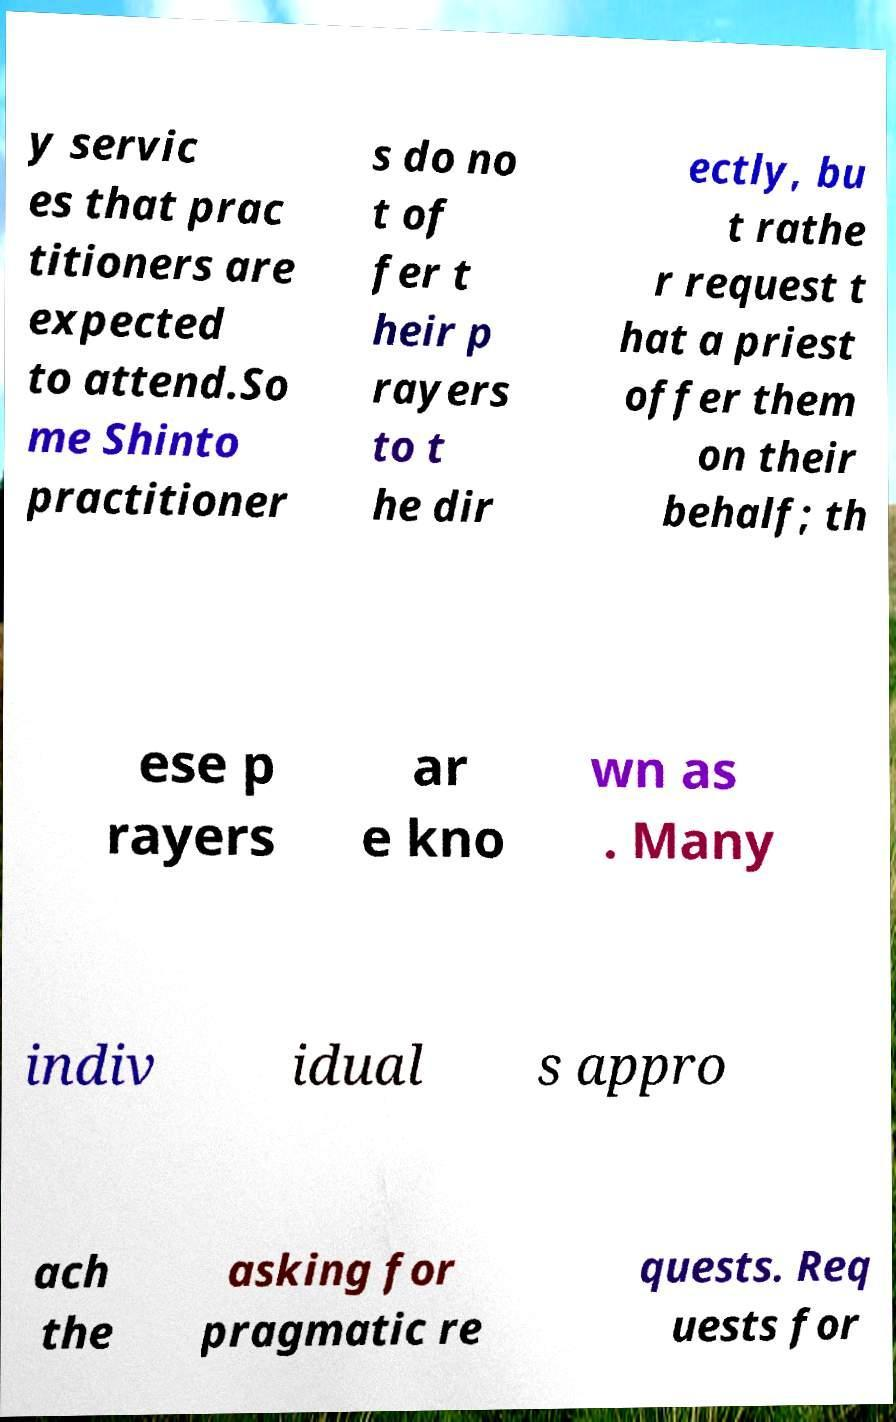Could you assist in decoding the text presented in this image and type it out clearly? y servic es that prac titioners are expected to attend.So me Shinto practitioner s do no t of fer t heir p rayers to t he dir ectly, bu t rathe r request t hat a priest offer them on their behalf; th ese p rayers ar e kno wn as . Many indiv idual s appro ach the asking for pragmatic re quests. Req uests for 